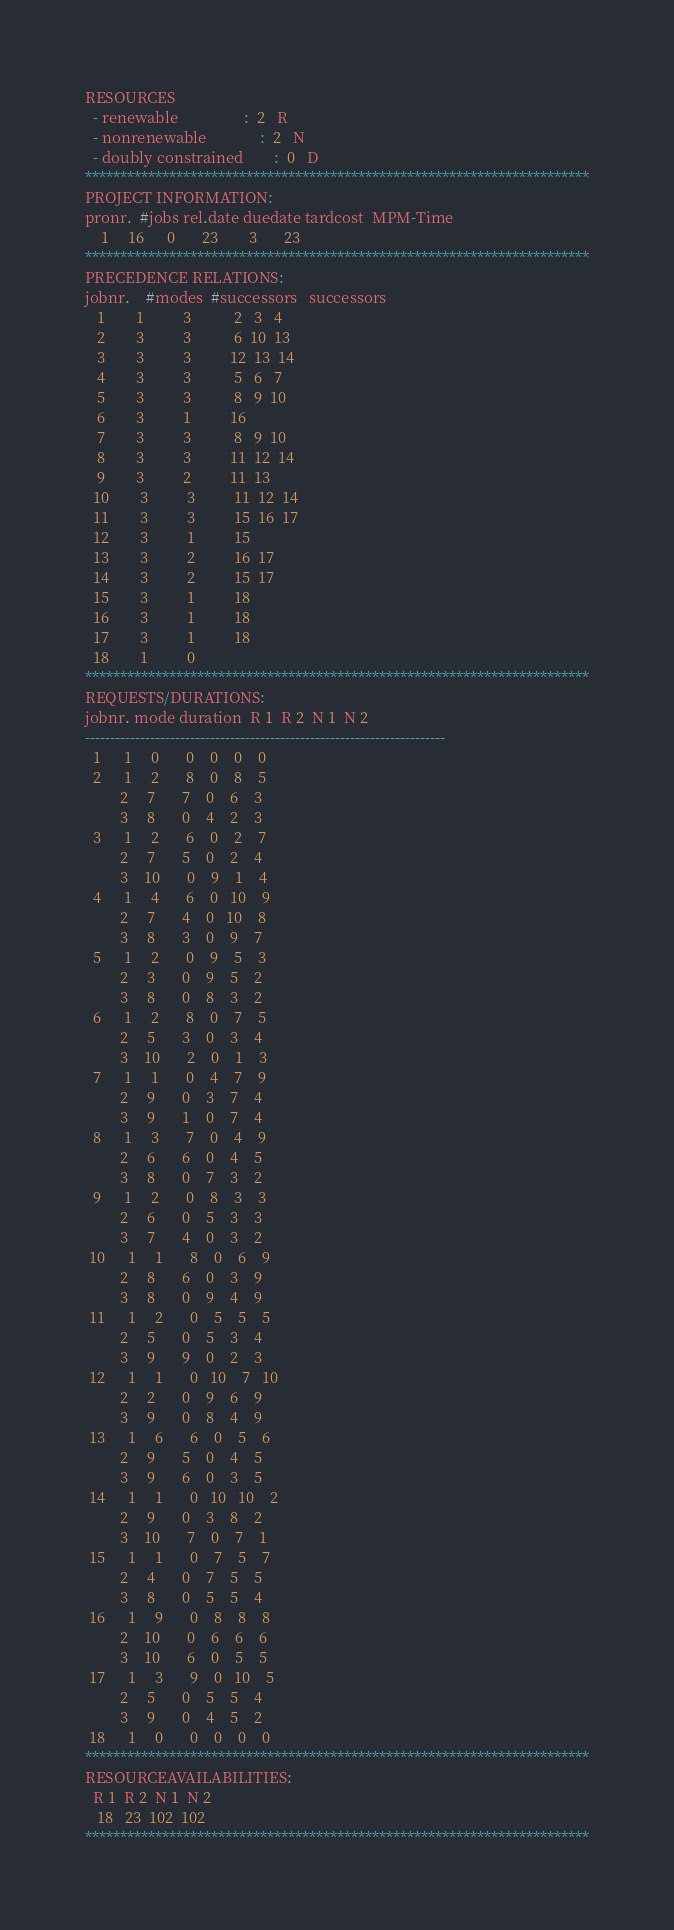<code> <loc_0><loc_0><loc_500><loc_500><_ObjectiveC_>RESOURCES
  - renewable                 :  2   R
  - nonrenewable              :  2   N
  - doubly constrained        :  0   D
************************************************************************
PROJECT INFORMATION:
pronr.  #jobs rel.date duedate tardcost  MPM-Time
    1     16      0       23        3       23
************************************************************************
PRECEDENCE RELATIONS:
jobnr.    #modes  #successors   successors
   1        1          3           2   3   4
   2        3          3           6  10  13
   3        3          3          12  13  14
   4        3          3           5   6   7
   5        3          3           8   9  10
   6        3          1          16
   7        3          3           8   9  10
   8        3          3          11  12  14
   9        3          2          11  13
  10        3          3          11  12  14
  11        3          3          15  16  17
  12        3          1          15
  13        3          2          16  17
  14        3          2          15  17
  15        3          1          18
  16        3          1          18
  17        3          1          18
  18        1          0        
************************************************************************
REQUESTS/DURATIONS:
jobnr. mode duration  R 1  R 2  N 1  N 2
------------------------------------------------------------------------
  1      1     0       0    0    0    0
  2      1     2       8    0    8    5
         2     7       7    0    6    3
         3     8       0    4    2    3
  3      1     2       6    0    2    7
         2     7       5    0    2    4
         3    10       0    9    1    4
  4      1     4       6    0   10    9
         2     7       4    0   10    8
         3     8       3    0    9    7
  5      1     2       0    9    5    3
         2     3       0    9    5    2
         3     8       0    8    3    2
  6      1     2       8    0    7    5
         2     5       3    0    3    4
         3    10       2    0    1    3
  7      1     1       0    4    7    9
         2     9       0    3    7    4
         3     9       1    0    7    4
  8      1     3       7    0    4    9
         2     6       6    0    4    5
         3     8       0    7    3    2
  9      1     2       0    8    3    3
         2     6       0    5    3    3
         3     7       4    0    3    2
 10      1     1       8    0    6    9
         2     8       6    0    3    9
         3     8       0    9    4    9
 11      1     2       0    5    5    5
         2     5       0    5    3    4
         3     9       9    0    2    3
 12      1     1       0   10    7   10
         2     2       0    9    6    9
         3     9       0    8    4    9
 13      1     6       6    0    5    6
         2     9       5    0    4    5
         3     9       6    0    3    5
 14      1     1       0   10   10    2
         2     9       0    3    8    2
         3    10       7    0    7    1
 15      1     1       0    7    5    7
         2     4       0    7    5    5
         3     8       0    5    5    4
 16      1     9       0    8    8    8
         2    10       0    6    6    6
         3    10       6    0    5    5
 17      1     3       9    0   10    5
         2     5       0    5    5    4
         3     9       0    4    5    2
 18      1     0       0    0    0    0
************************************************************************
RESOURCEAVAILABILITIES:
  R 1  R 2  N 1  N 2
   18   23  102  102
************************************************************************
</code> 